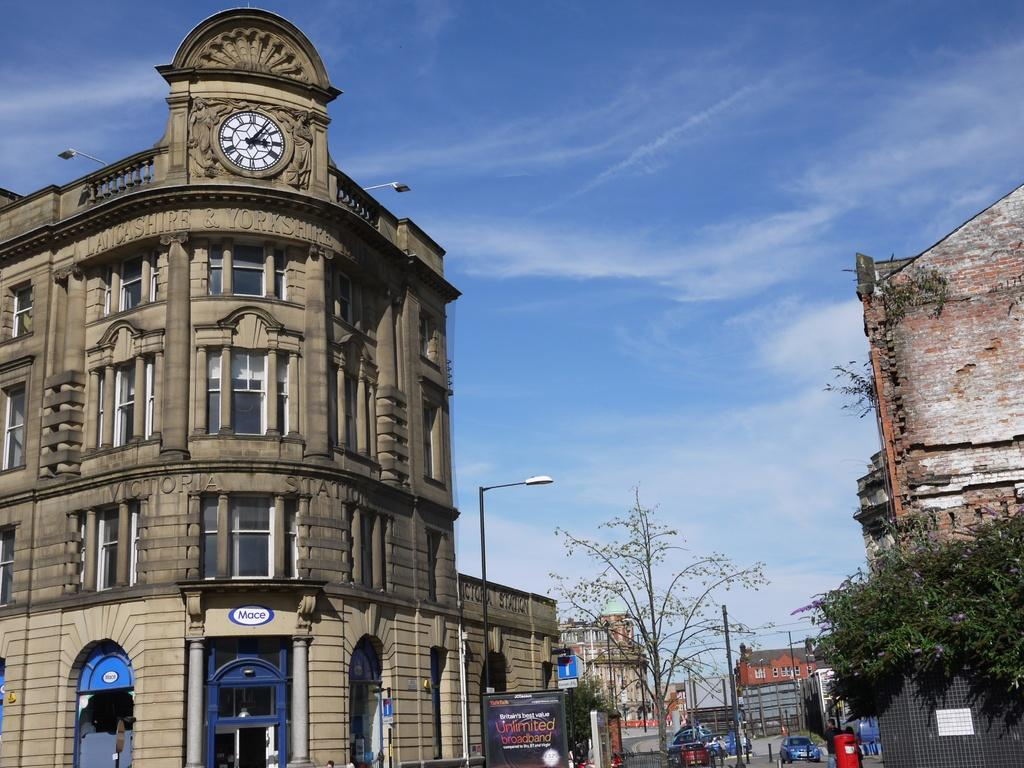What can be seen on the road in the image? There are vehicles on the road in the image. What structures are present in the image? There are poles, a post box, trees, banners, buildings with windows, and a clock in the image. What objects can be found in the image? There are some objects in the image. What is visible in the background of the image? The sky is visible in the background of the image. What type of pleasure can be seen enjoying the zephyr on the top of the post box in the image? There is no pleasure or zephyr present in the image, and the post box is not depicted as having a top. 